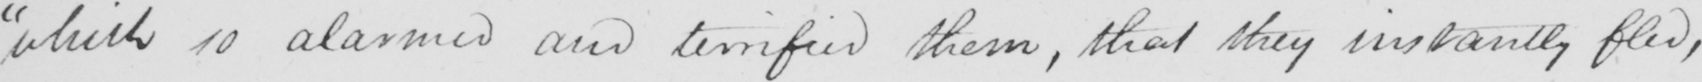What is written in this line of handwriting? which so alarmed and terrified them, that they instantly fled, 